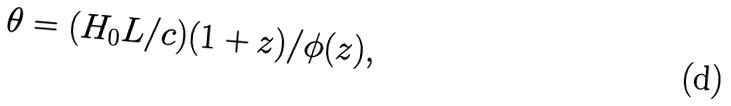<formula> <loc_0><loc_0><loc_500><loc_500>\theta = ( H _ { 0 } L / c ) ( 1 + z ) / \phi ( z ) ,</formula> 